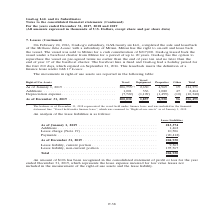According to Gaslog's financial document, How much was Methane Julia Louise sold for? According to the financial document, $217,000 (in thousands). The relevant text states: "sel was sold to Mitsui for a cash consideration of $217,000. GasLog leased back the vessel under a bareboat charter from Mitsui for a period of up to 20 years...." Also, Which company was the vessel sold to? According to the financial document, Mitsui. The relevant text states: "of the Methane Julia Louise with a subsidiary of Mitsui. Mitsui has the right to on-sell and lease back the vessel. The vessel was sold to Mitsui for a cas of the Methane Julia Louise with a subsidiar..." Also, What are the components of right-of use assets? The document contains multiple relevant values: Vessel, Vessel Equipment, Properties, Other. From the document: "Vessel Right-of-Use Assets Vessel Equipment Properties Other Total l Right-of-Use Assets Vessel Equipment Properties Other Total Vessel Right-of-Use A..." Additionally, Which month was the vessel equipment higher? According to the financial document, January. The relevant text states: "As of January 1, 2019 . 206,753 (*) 2,630 4,969 19 214,371 Additions . 1,001 336 1,080 47 2,464 Depreciation expe..." Also, can you calculate: What was the change in properties from start to end 2019? Based on the calculation: 4,969 - 4,550 , the result is 419 (in thousands). This is based on the information: "As of December 31, 2019 . 200,032 1,857 4,550 56 206,495 As of January 1, 2019 . 206,753 (*) 2,630 4,969 19 214,371 Additions . 1,001 336 1,080 47 2,464 Depreciation expense . (7,722) (1,109) (1,499) ..." The key data points involved are: 4,550, 4,969. Also, can you calculate: What was the percentage change in total right-of use assets  from start to end 2019? To answer this question, I need to perform calculations using the financial data. The calculation is: (206,495 - 214,371)/214,371 , which equals -3.67 (percentage). This is based on the information: "s of January 1, 2019 . 206,753 (*) 2,630 4,969 19 214,371 Additions . 1,001 336 1,080 47 2,464 Depreciation expense . (7,722) (1,109) (1,499) (10) (10,340) As of December 31, 2019 . 200,032 1,857 4,55..." The key data points involved are: 206,495, 214,371. 